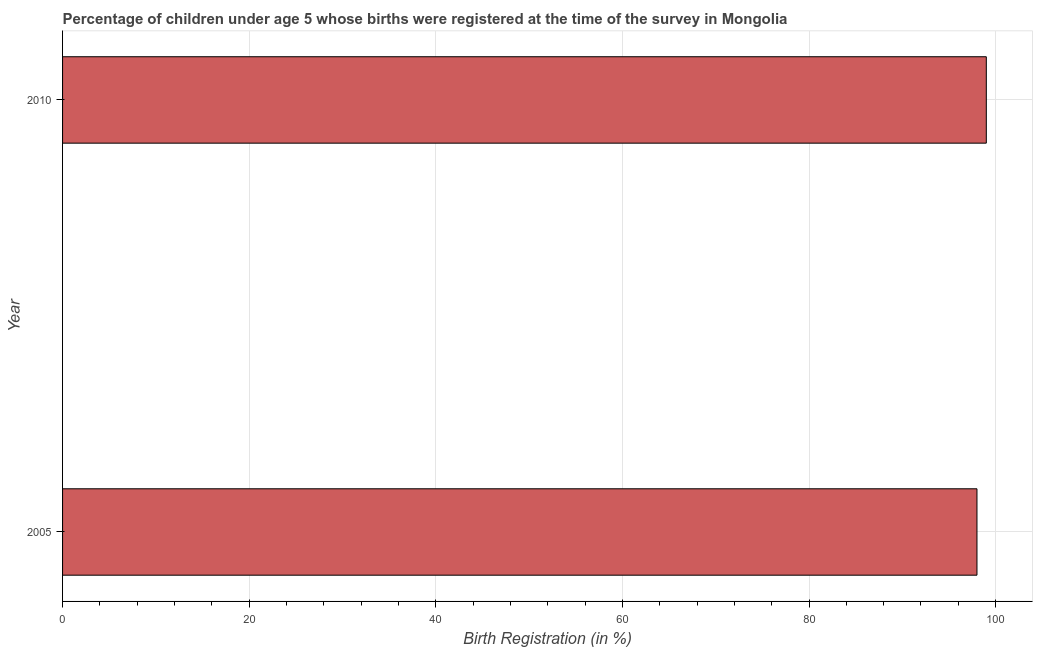Does the graph contain grids?
Your answer should be compact. Yes. What is the title of the graph?
Provide a succinct answer. Percentage of children under age 5 whose births were registered at the time of the survey in Mongolia. What is the label or title of the X-axis?
Your response must be concise. Birth Registration (in %). What is the label or title of the Y-axis?
Keep it short and to the point. Year. Across all years, what is the maximum birth registration?
Your answer should be very brief. 99. Across all years, what is the minimum birth registration?
Provide a short and direct response. 98. In which year was the birth registration maximum?
Make the answer very short. 2010. What is the sum of the birth registration?
Make the answer very short. 197. What is the difference between the birth registration in 2005 and 2010?
Offer a very short reply. -1. What is the median birth registration?
Give a very brief answer. 98.5. In how many years, is the birth registration greater than 48 %?
Offer a very short reply. 2. Is the birth registration in 2005 less than that in 2010?
Make the answer very short. Yes. In how many years, is the birth registration greater than the average birth registration taken over all years?
Provide a succinct answer. 1. How many bars are there?
Make the answer very short. 2. Are all the bars in the graph horizontal?
Offer a terse response. Yes. How many years are there in the graph?
Offer a very short reply. 2. What is the difference between two consecutive major ticks on the X-axis?
Make the answer very short. 20. Are the values on the major ticks of X-axis written in scientific E-notation?
Provide a short and direct response. No. What is the Birth Registration (in %) of 2005?
Give a very brief answer. 98. What is the difference between the Birth Registration (in %) in 2005 and 2010?
Offer a terse response. -1. 